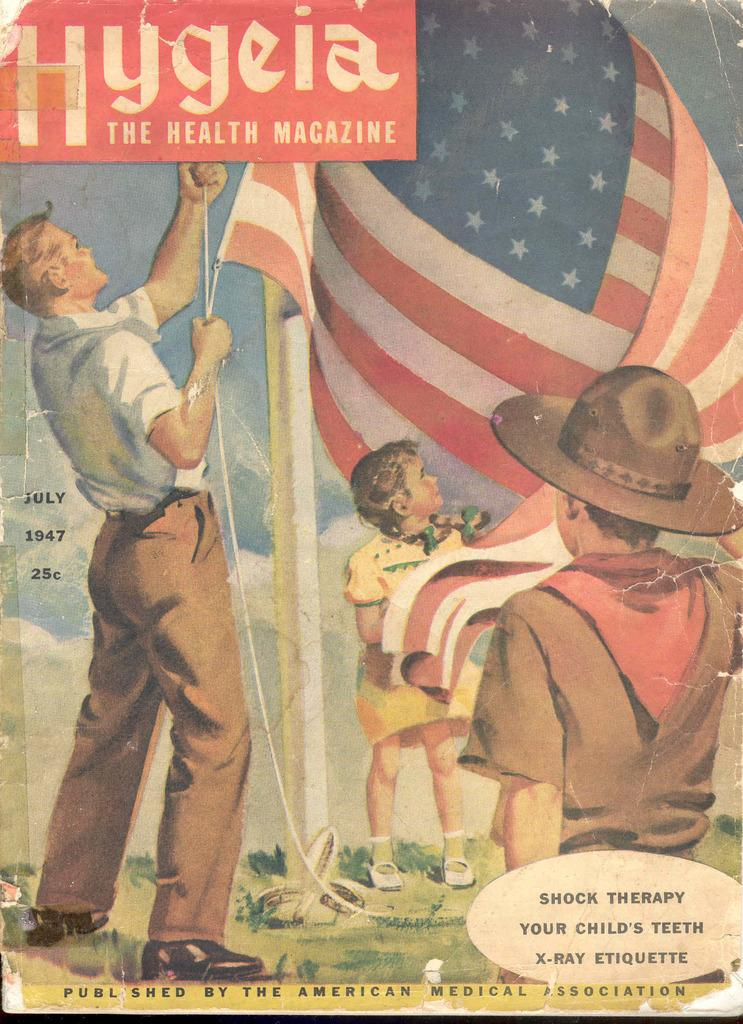How many people are present in the image? There are three people in the image. What can be seen on the front page of a book in the image? There is a flag on the front page of a book in the image. What type of yoke is being used by the people in the image? There is no yoke present in the image; it features three people and a book with a flag on its front page. 